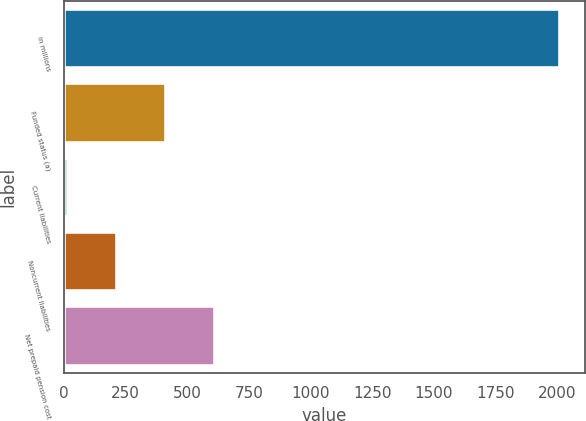Convert chart to OTSL. <chart><loc_0><loc_0><loc_500><loc_500><bar_chart><fcel>in millions<fcel>Funded status (a)<fcel>Current liabilities<fcel>Noncurrent liabilities<fcel>Net prepaid pension cost<nl><fcel>2013<fcel>413.8<fcel>14<fcel>213.9<fcel>613.7<nl></chart> 